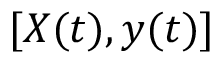Convert formula to latex. <formula><loc_0><loc_0><loc_500><loc_500>[ X ( t ) , y ( t ) ]</formula> 